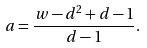Convert formula to latex. <formula><loc_0><loc_0><loc_500><loc_500>a = \frac { w - d ^ { 2 } + d - 1 } { d - 1 } .</formula> 